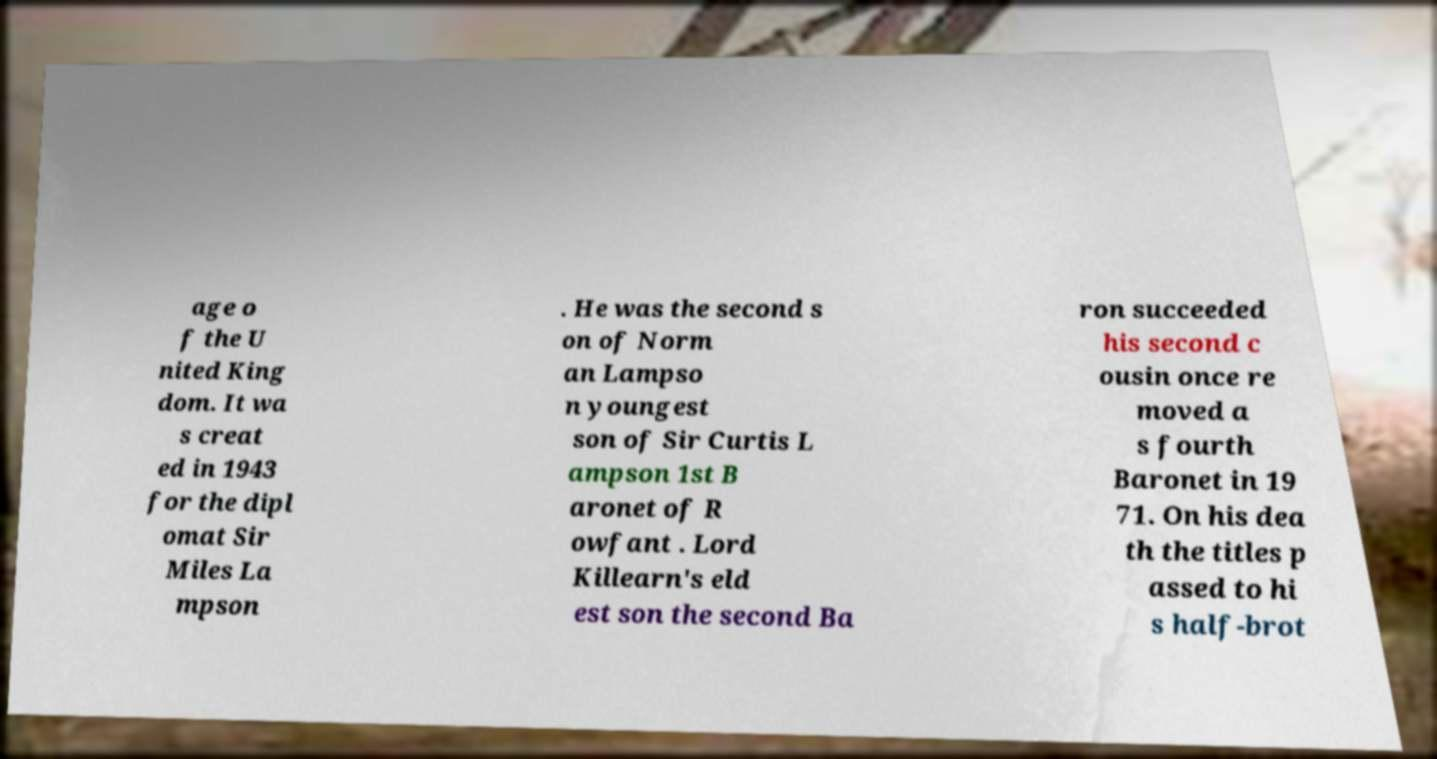Can you accurately transcribe the text from the provided image for me? age o f the U nited King dom. It wa s creat ed in 1943 for the dipl omat Sir Miles La mpson . He was the second s on of Norm an Lampso n youngest son of Sir Curtis L ampson 1st B aronet of R owfant . Lord Killearn's eld est son the second Ba ron succeeded his second c ousin once re moved a s fourth Baronet in 19 71. On his dea th the titles p assed to hi s half-brot 